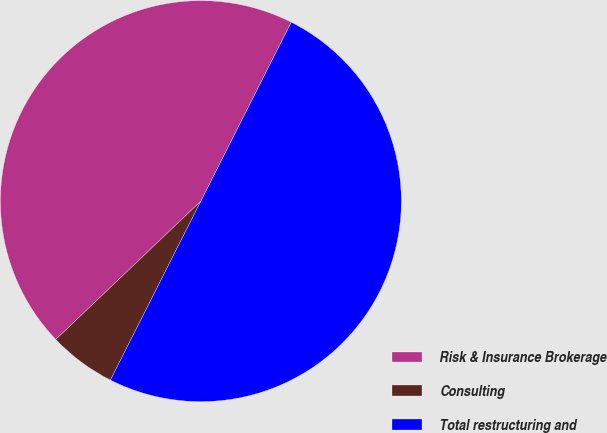<chart> <loc_0><loc_0><loc_500><loc_500><pie_chart><fcel>Risk & Insurance Brokerage<fcel>Consulting<fcel>Total restructuring and<nl><fcel>44.57%<fcel>5.43%<fcel>50.0%<nl></chart> 